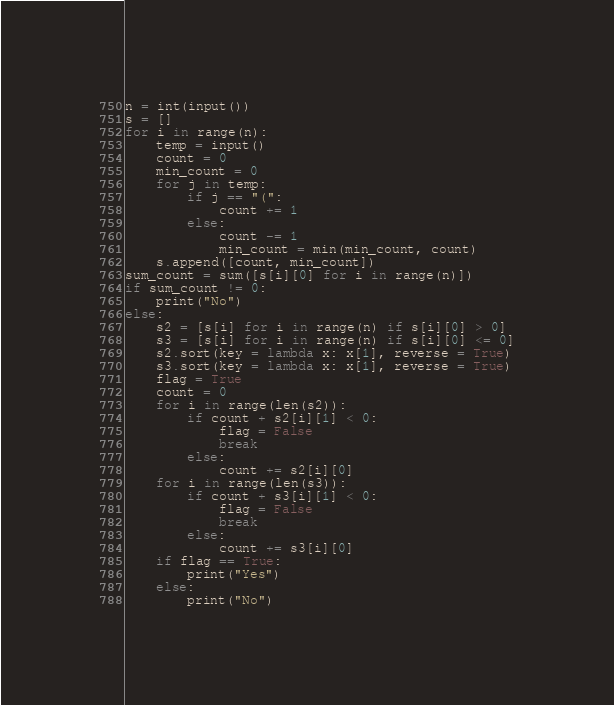Convert code to text. <code><loc_0><loc_0><loc_500><loc_500><_Python_>n = int(input())
s = []
for i in range(n):
    temp = input()
    count = 0
    min_count = 0
    for j in temp:
        if j == "(":
            count += 1
        else:
            count -= 1
            min_count = min(min_count, count)
    s.append([count, min_count])
sum_count = sum([s[i][0] for i in range(n)])
if sum_count != 0:
    print("No")
else:
    s2 = [s[i] for i in range(n) if s[i][0] > 0]
    s3 = [s[i] for i in range(n) if s[i][0] <= 0]
    s2.sort(key = lambda x: x[1], reverse = True)
    s3.sort(key = lambda x: x[1], reverse = True)
    flag = True
    count = 0
    for i in range(len(s2)):
        if count + s2[i][1] < 0:
            flag = False
            break
        else:
            count += s2[i][0]
    for i in range(len(s3)):
        if count + s3[i][1] < 0:
            flag = False
            break
        else:
            count += s3[i][0]
    if flag == True:
        print("Yes")
    else:
        print("No")</code> 